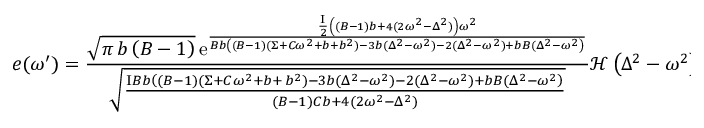Convert formula to latex. <formula><loc_0><loc_0><loc_500><loc_500>e ( \omega ^ { \prime } ) = \frac { \sqrt { \pi \, b \left ( B - 1 \right ) } \, { \mathrm e } ^ { \frac { \frac { I } { 2 } \left ( ( B - 1 ) b + 4 ( 2 \omega ^ { 2 } - \Delta ^ { 2 } ) \right ) \omega ^ { 2 } } { B b \left ( ( B - 1 ) ( \Sigma + C \omega ^ { 2 } + b + b ^ { 2 } ) - 3 b ( \Delta ^ { 2 } - \omega ^ { 2 } ) - 2 ( \Delta ^ { 2 } - \omega ^ { 2 } ) + b B ( \Delta ^ { 2 } - \omega ^ { 2 } \right ) } } } { \sqrt { \frac { I B b \left ( ( B - 1 ) ( \Sigma + C \omega ^ { 2 } + b + \, b ^ { 2 } ) - 3 b ( \Delta ^ { 2 } - \omega ^ { 2 } ) - 2 ( \Delta ^ { 2 } - \omega ^ { 2 } ) + b B ( \Delta ^ { 2 } - \omega ^ { 2 } \right ) } { ( B - 1 ) C b + 4 ( 2 \omega ^ { 2 } - \Delta ^ { 2 } ) } } } \mathcal { H } \left ( \Delta ^ { 2 } - \omega ^ { 2 } \right ) ,</formula> 